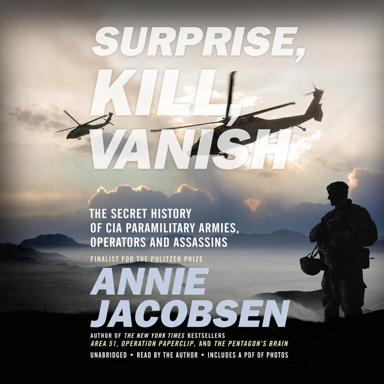What is the primary topic of this book? The primary focus of "Surprise, Kill, Vanish" is on the covert aspects of the CIA, specifically detailing the organization’s paramilitary units, its operators, and the secretive assassinations carried out by its operatives. It provides an in-depth view of the shadowy side of American intelligence. 